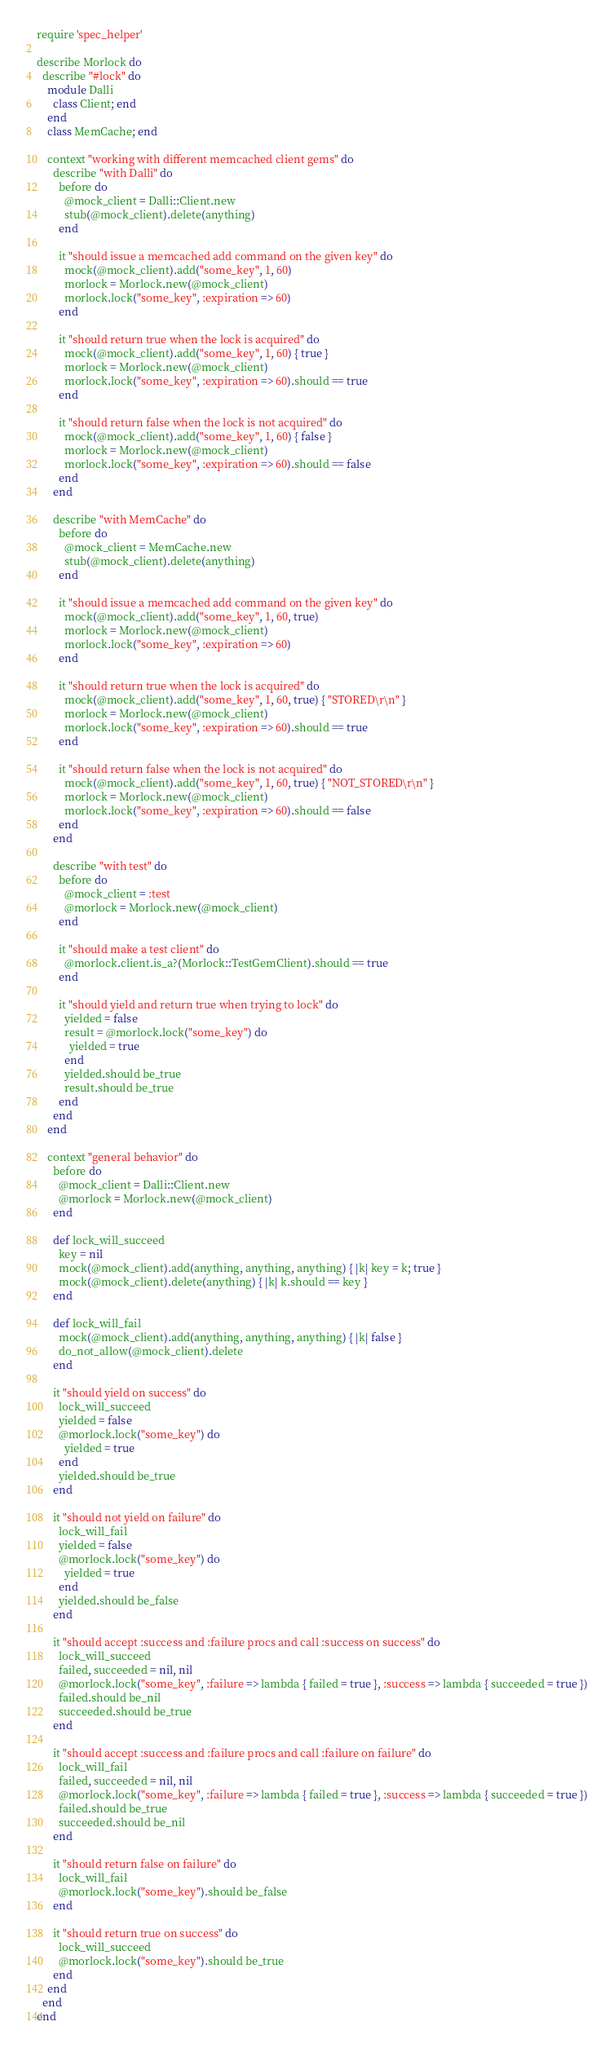Convert code to text. <code><loc_0><loc_0><loc_500><loc_500><_Ruby_>require 'spec_helper'

describe Morlock do
  describe "#lock" do
    module Dalli
      class Client; end
    end
    class MemCache; end

    context "working with different memcached client gems" do
      describe "with Dalli" do
        before do
          @mock_client = Dalli::Client.new
          stub(@mock_client).delete(anything)
        end

        it "should issue a memcached add command on the given key" do
          mock(@mock_client).add("some_key", 1, 60)
          morlock = Morlock.new(@mock_client)
          morlock.lock("some_key", :expiration => 60)
        end

        it "should return true when the lock is acquired" do
          mock(@mock_client).add("some_key", 1, 60) { true }
          morlock = Morlock.new(@mock_client)
          morlock.lock("some_key", :expiration => 60).should == true
        end

        it "should return false when the lock is not acquired" do
          mock(@mock_client).add("some_key", 1, 60) { false }
          morlock = Morlock.new(@mock_client)
          morlock.lock("some_key", :expiration => 60).should == false
        end
      end

      describe "with MemCache" do
        before do
          @mock_client = MemCache.new
          stub(@mock_client).delete(anything)
        end

        it "should issue a memcached add command on the given key" do
          mock(@mock_client).add("some_key", 1, 60, true)
          morlock = Morlock.new(@mock_client)
          morlock.lock("some_key", :expiration => 60)
        end

        it "should return true when the lock is acquired" do
          mock(@mock_client).add("some_key", 1, 60, true) { "STORED\r\n" }
          morlock = Morlock.new(@mock_client)
          morlock.lock("some_key", :expiration => 60).should == true
        end

        it "should return false when the lock is not acquired" do
          mock(@mock_client).add("some_key", 1, 60, true) { "NOT_STORED\r\n" }
          morlock = Morlock.new(@mock_client)
          morlock.lock("some_key", :expiration => 60).should == false
        end
      end

      describe "with test" do
        before do
          @mock_client = :test
          @morlock = Morlock.new(@mock_client)
        end

        it "should make a test client" do
          @morlock.client.is_a?(Morlock::TestGemClient).should == true
        end

        it "should yield and return true when trying to lock" do
          yielded = false
          result = @morlock.lock("some_key") do
            yielded = true
          end
          yielded.should be_true
          result.should be_true
        end
      end
    end

    context "general behavior" do
      before do
        @mock_client = Dalli::Client.new
        @morlock = Morlock.new(@mock_client)
      end

      def lock_will_succeed
        key = nil
        mock(@mock_client).add(anything, anything, anything) { |k| key = k; true }
        mock(@mock_client).delete(anything) { |k| k.should == key }
      end

      def lock_will_fail
        mock(@mock_client).add(anything, anything, anything) { |k| false }
        do_not_allow(@mock_client).delete
      end

      it "should yield on success" do
        lock_will_succeed
        yielded = false
        @morlock.lock("some_key") do
          yielded = true
        end
        yielded.should be_true
      end

      it "should not yield on failure" do
        lock_will_fail
        yielded = false
        @morlock.lock("some_key") do
          yielded = true
        end
        yielded.should be_false
      end

      it "should accept :success and :failure procs and call :success on success" do
        lock_will_succeed
        failed, succeeded = nil, nil
        @morlock.lock("some_key", :failure => lambda { failed = true }, :success => lambda { succeeded = true })
        failed.should be_nil
        succeeded.should be_true
      end

      it "should accept :success and :failure procs and call :failure on failure" do
        lock_will_fail
        failed, succeeded = nil, nil
        @morlock.lock("some_key", :failure => lambda { failed = true }, :success => lambda { succeeded = true })
        failed.should be_true
        succeeded.should be_nil
      end

      it "should return false on failure" do
        lock_will_fail
        @morlock.lock("some_key").should be_false
      end

      it "should return true on success" do
        lock_will_succeed
        @morlock.lock("some_key").should be_true
      end
    end
  end
end</code> 